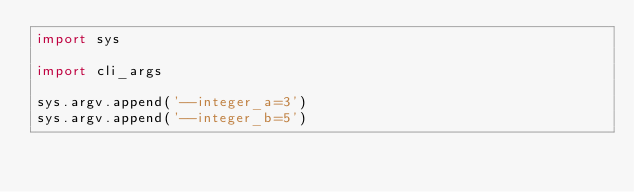Convert code to text. <code><loc_0><loc_0><loc_500><loc_500><_Python_>import sys

import cli_args

sys.argv.append('--integer_a=3')
sys.argv.append('--integer_b=5')
</code> 